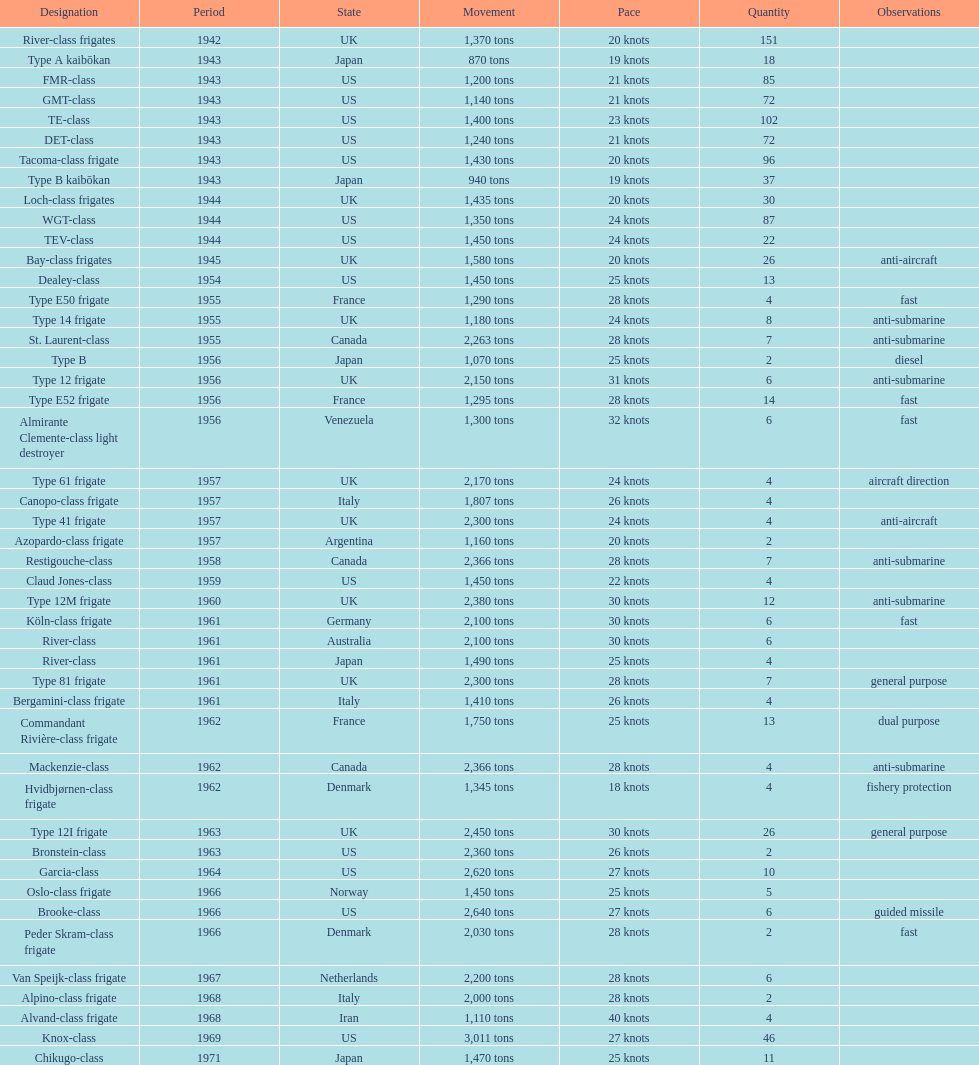Which name has the largest displacement? Knox-class. 